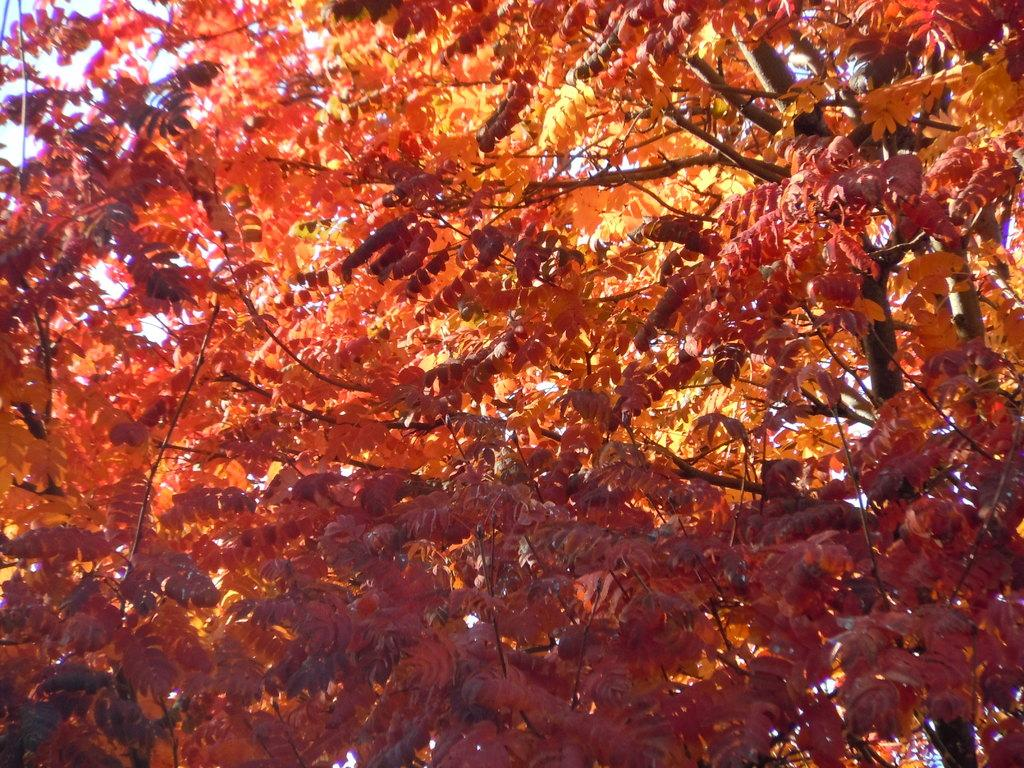What type of plant can be seen in the image? There is a tree in the image. What part of the natural environment is visible in the image? The sky is visible in the image. How many plates can be seen stacked on the tree in the image? There are no plates present in the image; it features a tree and the sky. What shape is the tree in the image? The shape of the tree cannot be determined from the image alone, as it only provides a general view of the tree. 